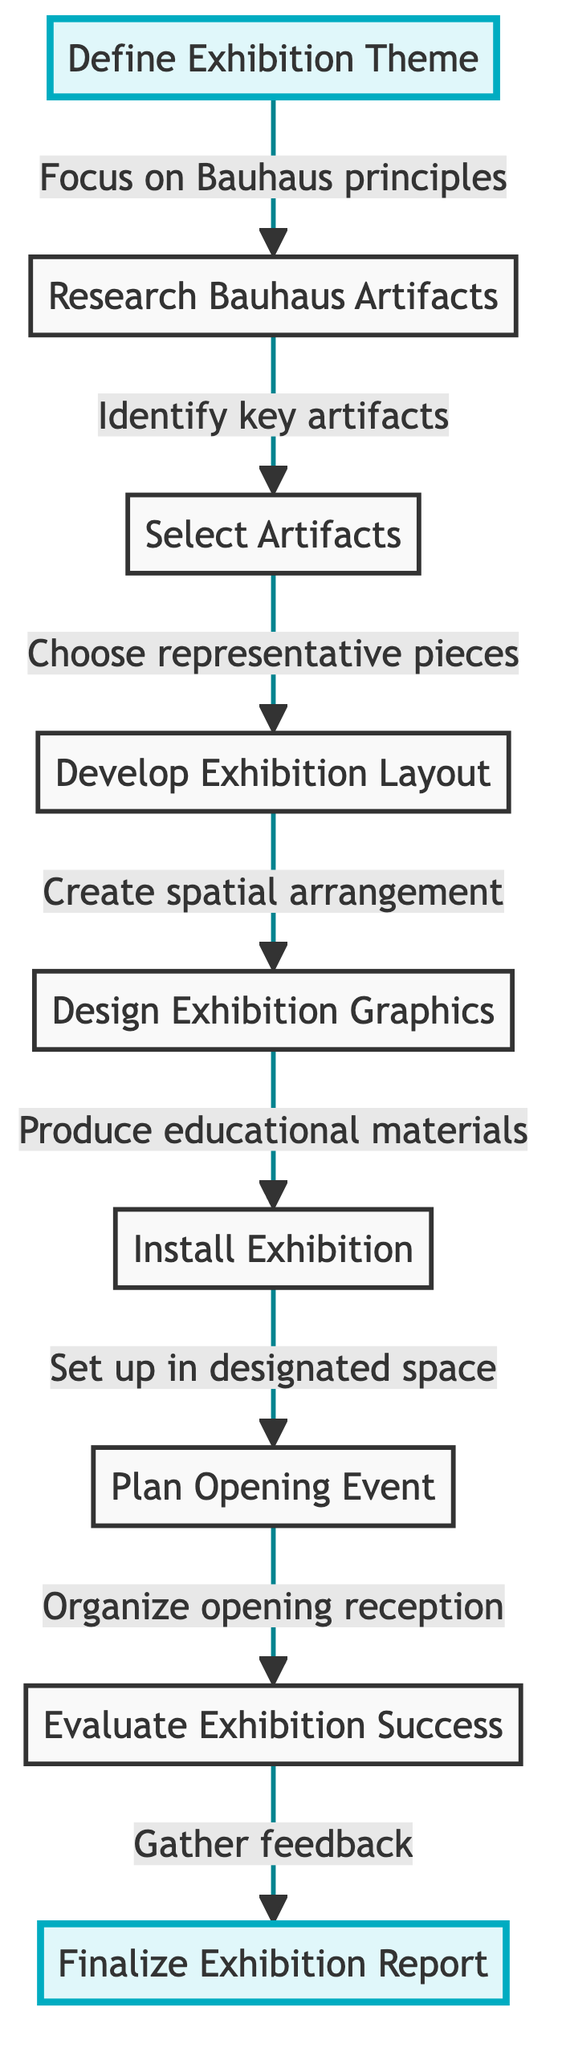What is the first step in the exhibition planning process? The first step is indicated by the starting node labeled "Define Exhibition Theme," which is where the process begins.
Answer: Define Exhibition Theme How many steps are there in the exhibition planning process? By counting all the nodes in the diagram, which represent steps, there are a total of 9 steps including the final report.
Answer: 9 What is the last step in the exhibition planning process? The last step is indicated by the final node labeled "Finalize Exhibition Report," which concludes the process.
Answer: Finalize Exhibition Report What is the description for the step "Select Artifacts"? The description provided in the diagram states it is about choosing representative pieces that showcase Bauhaus aesthetics and functionality.
Answer: Choose representative pieces that showcase Bauhaus aesthetics and functionality Which step comes after "Design Exhibition Graphics"? The diagram shows that "Install Exhibition" follows "Design Exhibition Graphics," indicating the next action in the flow.
Answer: Install Exhibition What is the purpose of the "Plan Opening Event" step? This step involves organizing an opening reception to attract visitors and media attention, as described in the diagram.
Answer: Organize an opening reception to attract visitors and media attention How does "Research Bauhaus Artifacts" relate to "Evaluate Exhibition Success"? "Research Bauhaus Artifacts" is an earlier step in the process that leads inevitably to various subsequent actions until reaching "Evaluate Exhibition Success" as a later step, indicating a site of assessment after execution.
Answer: Research Bauhaus Artifacts leads to Evaluate Exhibition Success Which step has the function of gathering feedback? The step titled "Evaluate Exhibition Success" is specifically designed to gather feedback and assess visitor engagement and satisfaction according to the diagram.
Answer: Evaluate Exhibition Success What action is taken after installing the exhibition? After "Install Exhibition," the next action is to "Plan Opening Event," indicating the process continues towards engagement with viewers.
Answer: Plan Opening Event 